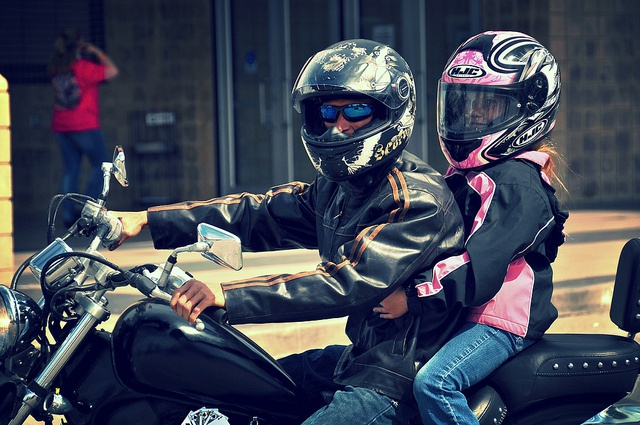Describe the objects in this image and their specific colors. I can see motorcycle in black, navy, gray, and darkgray tones, people in black, navy, blue, and gray tones, people in black, navy, blue, and lightgray tones, people in black, navy, brown, and purple tones, and backpack in black, navy, purple, and darkblue tones in this image. 